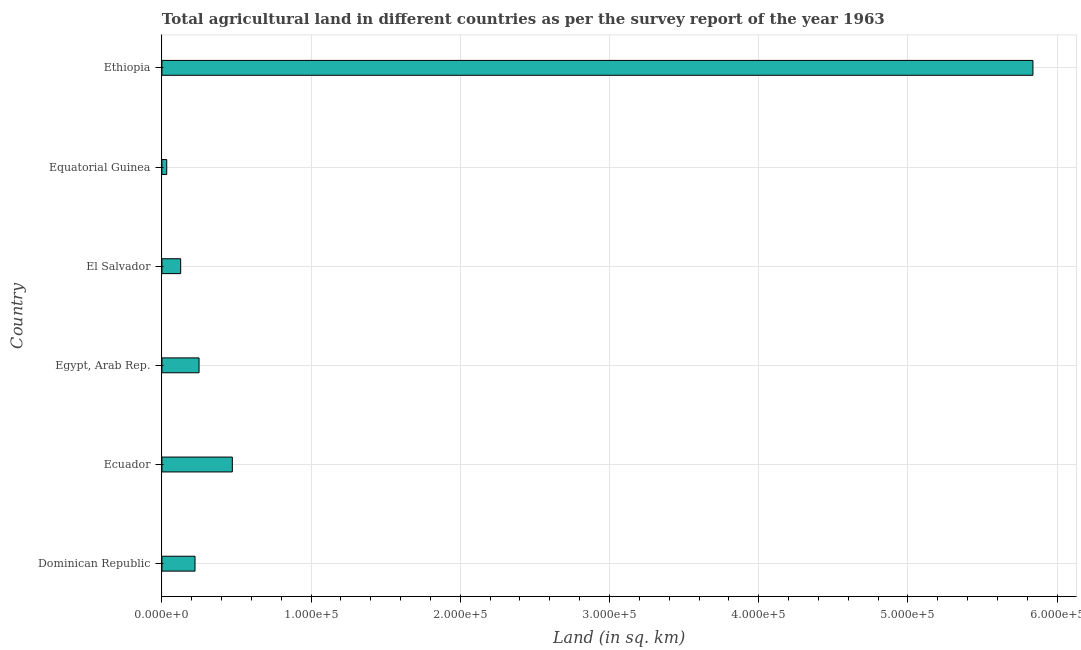Does the graph contain any zero values?
Offer a terse response. No. Does the graph contain grids?
Your response must be concise. Yes. What is the title of the graph?
Ensure brevity in your answer.  Total agricultural land in different countries as per the survey report of the year 1963. What is the label or title of the X-axis?
Your answer should be compact. Land (in sq. km). What is the label or title of the Y-axis?
Your answer should be compact. Country. What is the agricultural land in Dominican Republic?
Provide a short and direct response. 2.22e+04. Across all countries, what is the maximum agricultural land?
Keep it short and to the point. 5.84e+05. Across all countries, what is the minimum agricultural land?
Make the answer very short. 3240. In which country was the agricultural land maximum?
Your response must be concise. Ethiopia. In which country was the agricultural land minimum?
Offer a very short reply. Equatorial Guinea. What is the sum of the agricultural land?
Keep it short and to the point. 6.94e+05. What is the difference between the agricultural land in Dominican Republic and Equatorial Guinea?
Provide a succinct answer. 1.90e+04. What is the average agricultural land per country?
Keep it short and to the point. 1.16e+05. What is the median agricultural land?
Provide a short and direct response. 2.36e+04. What is the ratio of the agricultural land in Egypt, Arab Rep. to that in El Salvador?
Ensure brevity in your answer.  1.98. Is the agricultural land in Ecuador less than that in Equatorial Guinea?
Provide a succinct answer. No. What is the difference between the highest and the second highest agricultural land?
Offer a very short reply. 5.37e+05. What is the difference between the highest and the lowest agricultural land?
Offer a terse response. 5.81e+05. Are all the bars in the graph horizontal?
Your answer should be compact. Yes. Are the values on the major ticks of X-axis written in scientific E-notation?
Keep it short and to the point. Yes. What is the Land (in sq. km) of Dominican Republic?
Provide a succinct answer. 2.22e+04. What is the Land (in sq. km) in Ecuador?
Make the answer very short. 4.72e+04. What is the Land (in sq. km) in Egypt, Arab Rep.?
Provide a succinct answer. 2.49e+04. What is the Land (in sq. km) of El Salvador?
Ensure brevity in your answer.  1.26e+04. What is the Land (in sq. km) in Equatorial Guinea?
Give a very brief answer. 3240. What is the Land (in sq. km) of Ethiopia?
Ensure brevity in your answer.  5.84e+05. What is the difference between the Land (in sq. km) in Dominican Republic and Ecuador?
Keep it short and to the point. -2.50e+04. What is the difference between the Land (in sq. km) in Dominican Republic and Egypt, Arab Rep.?
Provide a short and direct response. -2700. What is the difference between the Land (in sq. km) in Dominican Republic and El Salvador?
Your answer should be very brief. 9620. What is the difference between the Land (in sq. km) in Dominican Republic and Equatorial Guinea?
Your response must be concise. 1.90e+04. What is the difference between the Land (in sq. km) in Dominican Republic and Ethiopia?
Make the answer very short. -5.62e+05. What is the difference between the Land (in sq. km) in Ecuador and Egypt, Arab Rep.?
Keep it short and to the point. 2.23e+04. What is the difference between the Land (in sq. km) in Ecuador and El Salvador?
Your response must be concise. 3.46e+04. What is the difference between the Land (in sq. km) in Ecuador and Equatorial Guinea?
Provide a succinct answer. 4.40e+04. What is the difference between the Land (in sq. km) in Ecuador and Ethiopia?
Make the answer very short. -5.37e+05. What is the difference between the Land (in sq. km) in Egypt, Arab Rep. and El Salvador?
Keep it short and to the point. 1.23e+04. What is the difference between the Land (in sq. km) in Egypt, Arab Rep. and Equatorial Guinea?
Keep it short and to the point. 2.17e+04. What is the difference between the Land (in sq. km) in Egypt, Arab Rep. and Ethiopia?
Offer a terse response. -5.59e+05. What is the difference between the Land (in sq. km) in El Salvador and Equatorial Guinea?
Provide a short and direct response. 9340. What is the difference between the Land (in sq. km) in El Salvador and Ethiopia?
Offer a very short reply. -5.71e+05. What is the difference between the Land (in sq. km) in Equatorial Guinea and Ethiopia?
Keep it short and to the point. -5.81e+05. What is the ratio of the Land (in sq. km) in Dominican Republic to that in Ecuador?
Keep it short and to the point. 0.47. What is the ratio of the Land (in sq. km) in Dominican Republic to that in Egypt, Arab Rep.?
Provide a short and direct response. 0.89. What is the ratio of the Land (in sq. km) in Dominican Republic to that in El Salvador?
Your answer should be compact. 1.76. What is the ratio of the Land (in sq. km) in Dominican Republic to that in Equatorial Guinea?
Provide a short and direct response. 6.85. What is the ratio of the Land (in sq. km) in Dominican Republic to that in Ethiopia?
Ensure brevity in your answer.  0.04. What is the ratio of the Land (in sq. km) in Ecuador to that in Egypt, Arab Rep.?
Give a very brief answer. 1.9. What is the ratio of the Land (in sq. km) in Ecuador to that in El Salvador?
Keep it short and to the point. 3.75. What is the ratio of the Land (in sq. km) in Ecuador to that in Equatorial Guinea?
Make the answer very short. 14.57. What is the ratio of the Land (in sq. km) in Ecuador to that in Ethiopia?
Provide a succinct answer. 0.08. What is the ratio of the Land (in sq. km) in Egypt, Arab Rep. to that in El Salvador?
Give a very brief answer. 1.98. What is the ratio of the Land (in sq. km) in Egypt, Arab Rep. to that in Equatorial Guinea?
Provide a short and direct response. 7.68. What is the ratio of the Land (in sq. km) in Egypt, Arab Rep. to that in Ethiopia?
Offer a very short reply. 0.04. What is the ratio of the Land (in sq. km) in El Salvador to that in Equatorial Guinea?
Give a very brief answer. 3.88. What is the ratio of the Land (in sq. km) in El Salvador to that in Ethiopia?
Keep it short and to the point. 0.02. What is the ratio of the Land (in sq. km) in Equatorial Guinea to that in Ethiopia?
Ensure brevity in your answer.  0.01. 